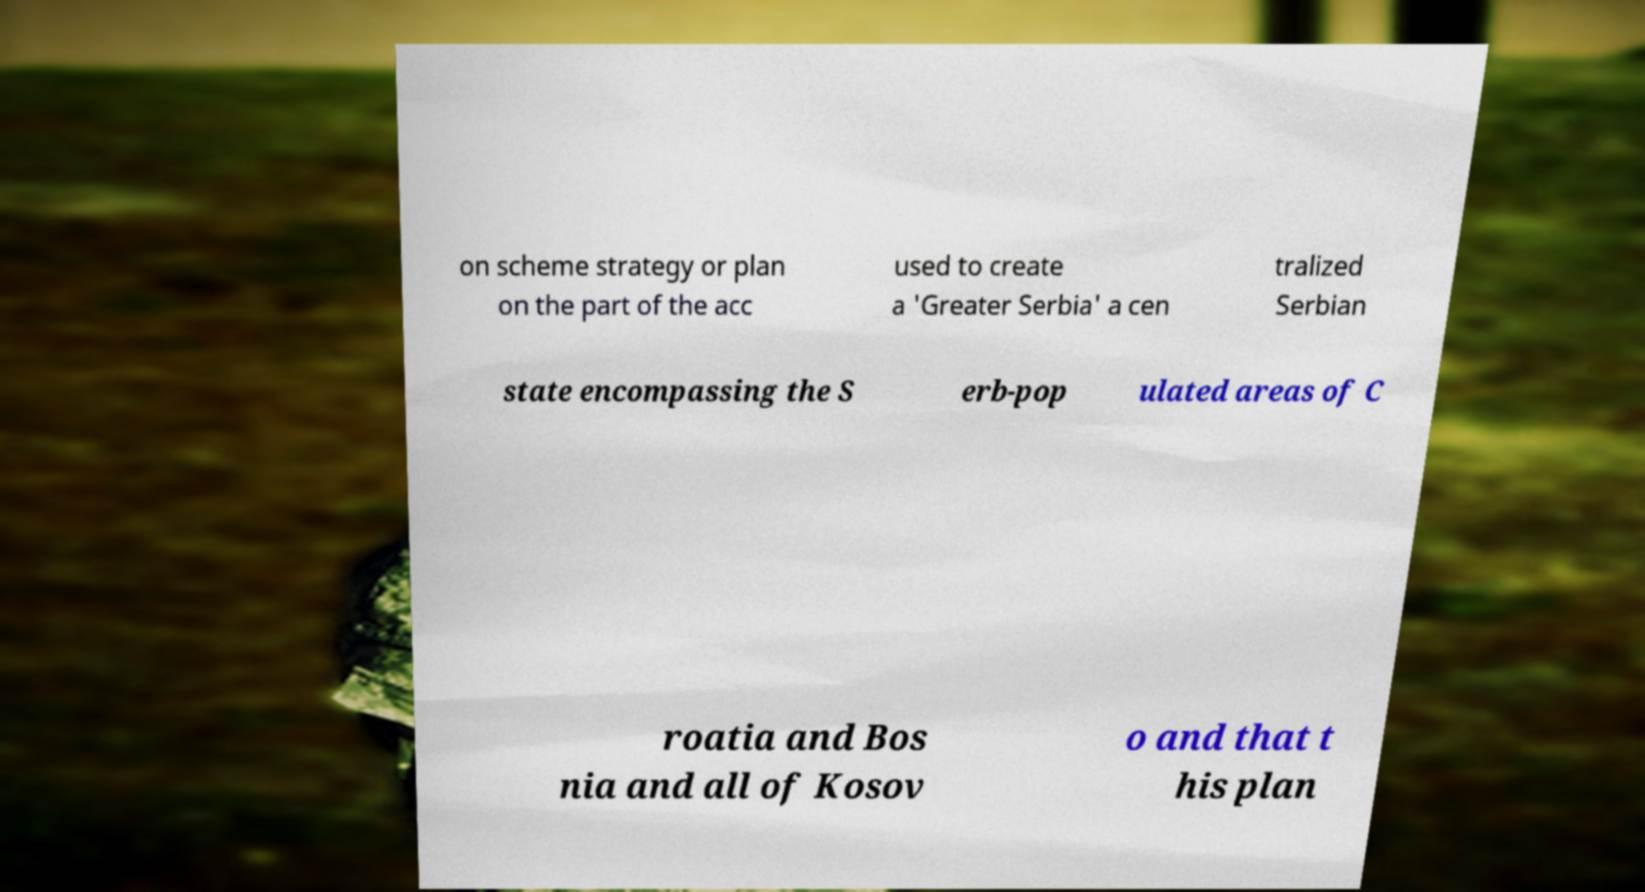I need the written content from this picture converted into text. Can you do that? on scheme strategy or plan on the part of the acc used to create a 'Greater Serbia' a cen tralized Serbian state encompassing the S erb-pop ulated areas of C roatia and Bos nia and all of Kosov o and that t his plan 